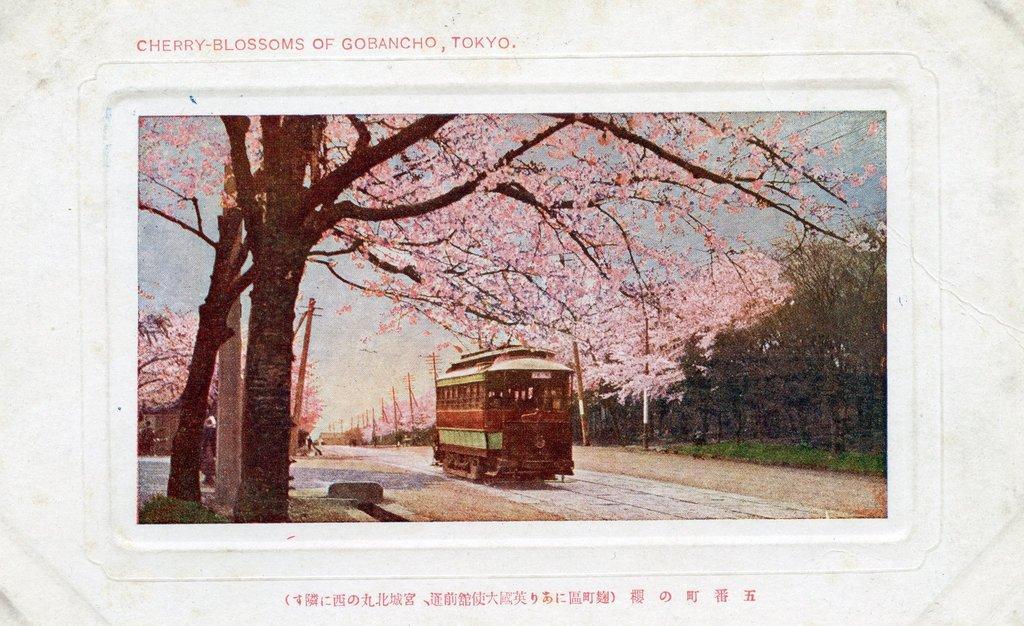Please provide a concise description of this image. In this picture I can see there is a train moving on the track and there are few trees, poles at right and there are few other trees here at left and it has pink flowers and the sky is clear. There is something written at the top and bottom of the image. 